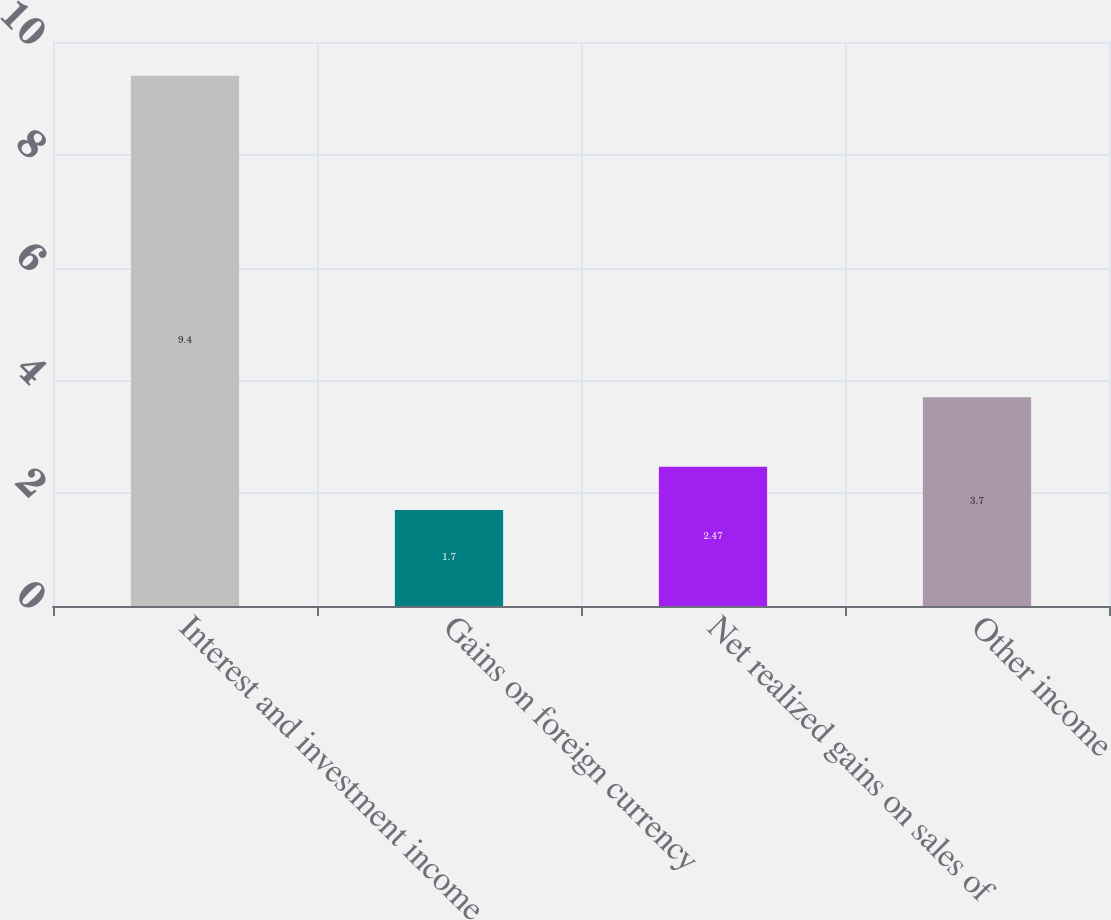Convert chart to OTSL. <chart><loc_0><loc_0><loc_500><loc_500><bar_chart><fcel>Interest and investment income<fcel>Gains on foreign currency<fcel>Net realized gains on sales of<fcel>Other income<nl><fcel>9.4<fcel>1.7<fcel>2.47<fcel>3.7<nl></chart> 